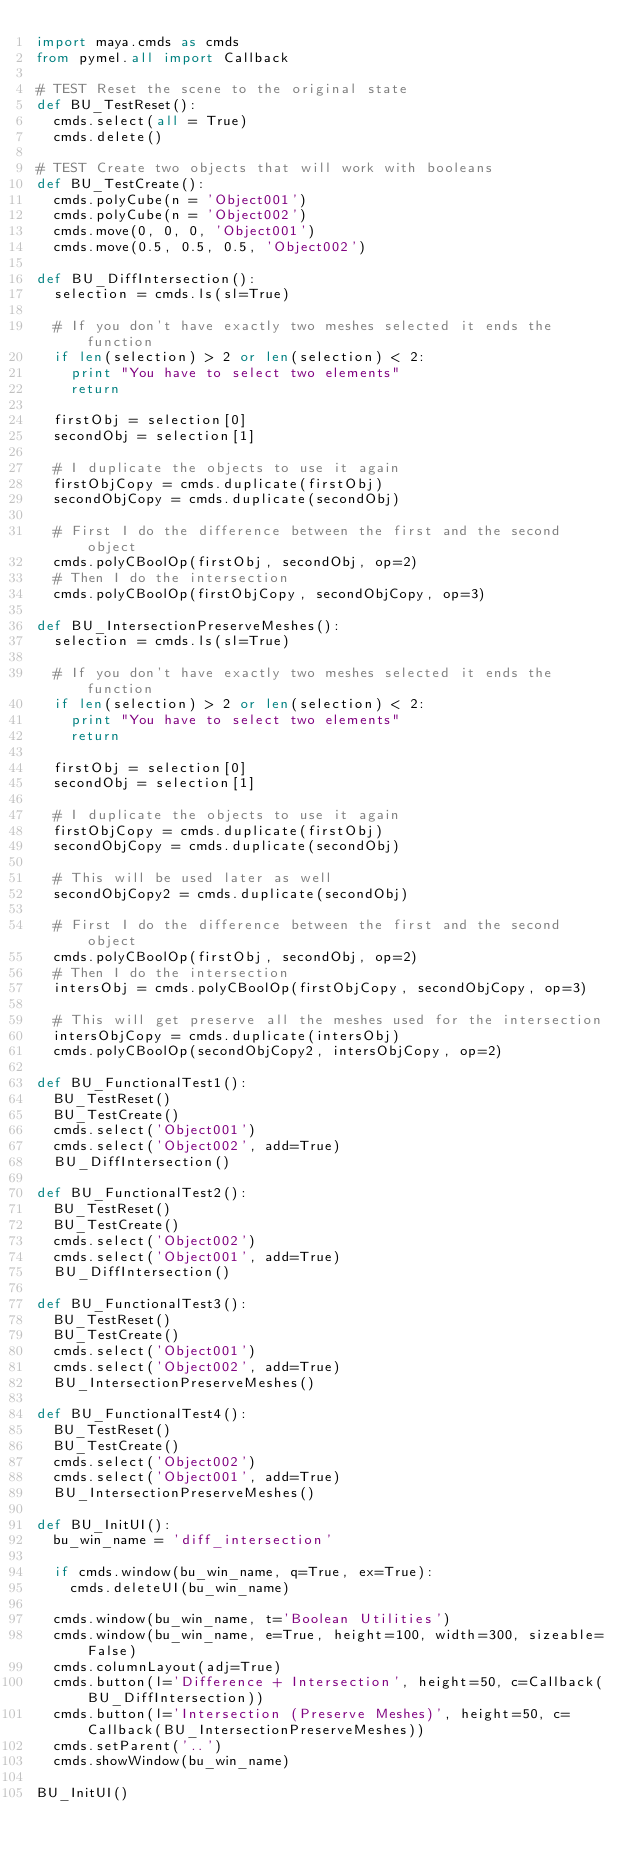<code> <loc_0><loc_0><loc_500><loc_500><_Python_>import maya.cmds as cmds
from pymel.all import Callback

# TEST Reset the scene to the original state
def BU_TestReset():
	cmds.select(all = True)
	cmds.delete()

# TEST Create two objects that will work with booleans
def BU_TestCreate():
	cmds.polyCube(n = 'Object001')
	cmds.polyCube(n = 'Object002')
	cmds.move(0, 0, 0, 'Object001')
	cmds.move(0.5, 0.5, 0.5, 'Object002')

def BU_DiffIntersection():
	selection = cmds.ls(sl=True)

	# If you don't have exactly two meshes selected it ends the function
	if len(selection) > 2 or len(selection) < 2:
		print "You have to select two elements"
		return

	firstObj = selection[0]
	secondObj = selection[1]

	# I duplicate the objects to use it again
	firstObjCopy = cmds.duplicate(firstObj)
	secondObjCopy = cmds.duplicate(secondObj)

	# First I do the difference between the first and the second object
	cmds.polyCBoolOp(firstObj, secondObj, op=2)
	# Then I do the intersection
	cmds.polyCBoolOp(firstObjCopy, secondObjCopy, op=3)

def BU_IntersectionPreserveMeshes():
	selection = cmds.ls(sl=True)

	# If you don't have exactly two meshes selected it ends the function
	if len(selection) > 2 or len(selection) < 2:
		print "You have to select two elements"
		return

	firstObj = selection[0]
	secondObj = selection[1]

	# I duplicate the objects to use it again
	firstObjCopy = cmds.duplicate(firstObj)
	secondObjCopy = cmds.duplicate(secondObj)

	# This will be used later as well
	secondObjCopy2 = cmds.duplicate(secondObj)

	# First I do the difference between the first and the second object
	cmds.polyCBoolOp(firstObj, secondObj, op=2)
	# Then I do the intersection
	intersObj = cmds.polyCBoolOp(firstObjCopy, secondObjCopy, op=3)

	# This will get preserve all the meshes used for the intersection
	intersObjCopy = cmds.duplicate(intersObj)
	cmds.polyCBoolOp(secondObjCopy2, intersObjCopy, op=2)

def BU_FunctionalTest1():
	BU_TestReset()
	BU_TestCreate()
	cmds.select('Object001')
	cmds.select('Object002', add=True)
	BU_DiffIntersection()

def BU_FunctionalTest2():
	BU_TestReset()
	BU_TestCreate()
	cmds.select('Object002')
	cmds.select('Object001', add=True)
	BU_DiffIntersection()

def BU_FunctionalTest3():
	BU_TestReset()
	BU_TestCreate()
	cmds.select('Object001')
	cmds.select('Object002', add=True)
	BU_IntersectionPreserveMeshes()

def BU_FunctionalTest4():
	BU_TestReset()
	BU_TestCreate()
	cmds.select('Object002')
	cmds.select('Object001', add=True)
	BU_IntersectionPreserveMeshes()

def BU_InitUI():
	bu_win_name = 'diff_intersection'

	if cmds.window(bu_win_name, q=True, ex=True):
		cmds.deleteUI(bu_win_name)

	cmds.window(bu_win_name, t='Boolean Utilities')
	cmds.window(bu_win_name, e=True, height=100, width=300, sizeable=False)
	cmds.columnLayout(adj=True)
	cmds.button(l='Difference + Intersection', height=50, c=Callback(BU_DiffIntersection))
	cmds.button(l='Intersection (Preserve Meshes)', height=50, c=Callback(BU_IntersectionPreserveMeshes))
	cmds.setParent('..')
	cmds.showWindow(bu_win_name)

BU_InitUI()
</code> 